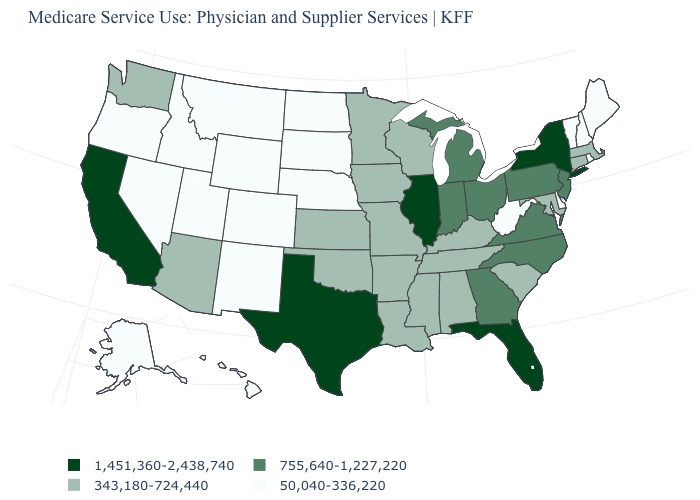Does the map have missing data?
Write a very short answer. No. What is the lowest value in the USA?
Short answer required. 50,040-336,220. Name the states that have a value in the range 343,180-724,440?
Give a very brief answer. Alabama, Arizona, Arkansas, Connecticut, Iowa, Kansas, Kentucky, Louisiana, Maryland, Massachusetts, Minnesota, Mississippi, Missouri, Oklahoma, South Carolina, Tennessee, Washington, Wisconsin. What is the value of New Jersey?
Answer briefly. 755,640-1,227,220. Name the states that have a value in the range 343,180-724,440?
Answer briefly. Alabama, Arizona, Arkansas, Connecticut, Iowa, Kansas, Kentucky, Louisiana, Maryland, Massachusetts, Minnesota, Mississippi, Missouri, Oklahoma, South Carolina, Tennessee, Washington, Wisconsin. Does New Hampshire have a higher value than Massachusetts?
Be succinct. No. Does Oklahoma have a higher value than West Virginia?
Be succinct. Yes. Does New York have the lowest value in the Northeast?
Keep it brief. No. What is the highest value in the South ?
Give a very brief answer. 1,451,360-2,438,740. Name the states that have a value in the range 755,640-1,227,220?
Give a very brief answer. Georgia, Indiana, Michigan, New Jersey, North Carolina, Ohio, Pennsylvania, Virginia. Name the states that have a value in the range 343,180-724,440?
Answer briefly. Alabama, Arizona, Arkansas, Connecticut, Iowa, Kansas, Kentucky, Louisiana, Maryland, Massachusetts, Minnesota, Mississippi, Missouri, Oklahoma, South Carolina, Tennessee, Washington, Wisconsin. What is the value of Idaho?
Keep it brief. 50,040-336,220. Name the states that have a value in the range 1,451,360-2,438,740?
Give a very brief answer. California, Florida, Illinois, New York, Texas. Does Alaska have the highest value in the West?
Give a very brief answer. No. Name the states that have a value in the range 1,451,360-2,438,740?
Give a very brief answer. California, Florida, Illinois, New York, Texas. 